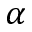Convert formula to latex. <formula><loc_0><loc_0><loc_500><loc_500>\alpha</formula> 